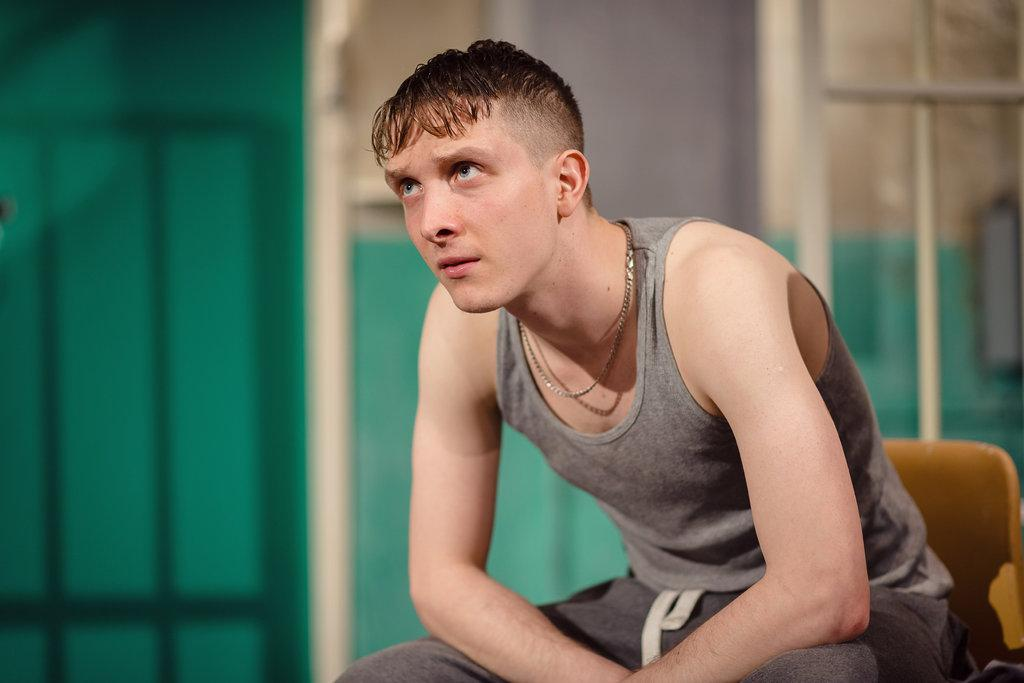Who is present in the image? There is a man in the image. What is the man doing in the image? The man is sitting on a chair. What is the man wearing in the image? The man is wearing a grey dress and a chain. What can be seen in the background of the image? There is a wall in the background of the image. What type of train can be seen passing by in the image? There is no train present in the image; it only features a man sitting on a chair. What is the cause of the thunder in the image? There is no thunder present in the image; it is a still image of a man sitting on a chair. 